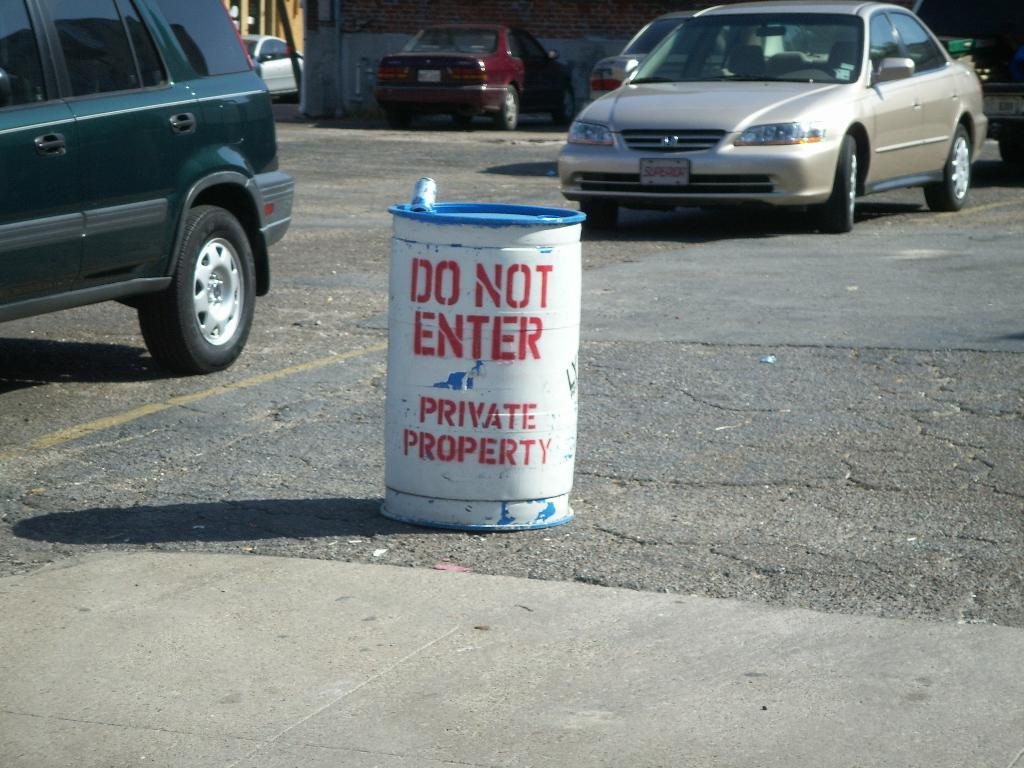<image>
Provide a brief description of the given image. A parking lot with a barrel stating "do not enter private property" 